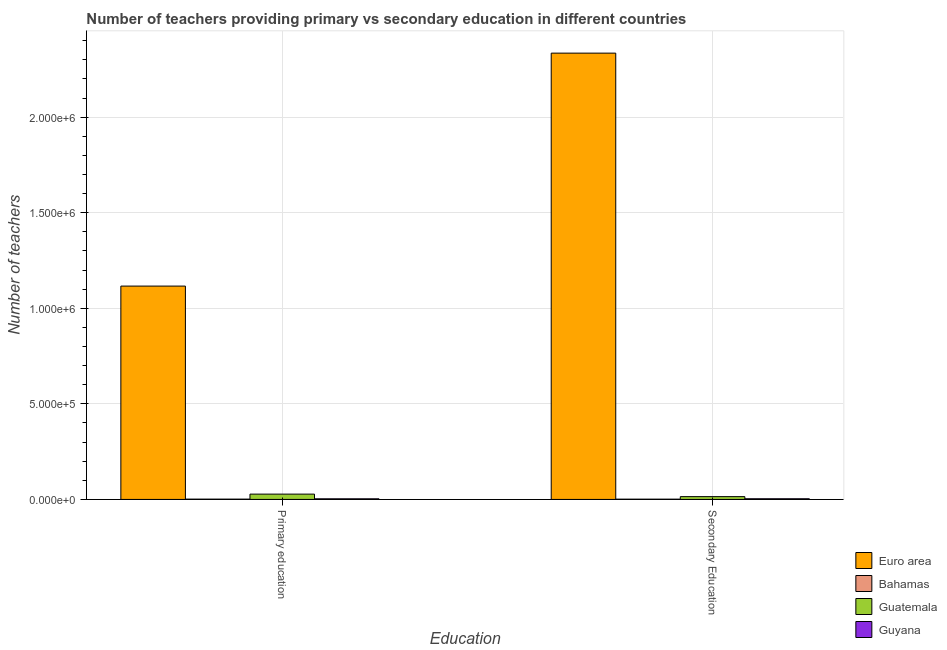How many different coloured bars are there?
Give a very brief answer. 4. How many bars are there on the 1st tick from the left?
Your response must be concise. 4. How many bars are there on the 1st tick from the right?
Offer a terse response. 4. What is the label of the 1st group of bars from the left?
Offer a very short reply. Primary education. What is the number of primary teachers in Guyana?
Provide a succinct answer. 3284. Across all countries, what is the maximum number of secondary teachers?
Ensure brevity in your answer.  2.34e+06. Across all countries, what is the minimum number of primary teachers?
Your response must be concise. 1561. In which country was the number of primary teachers minimum?
Make the answer very short. Bahamas. What is the total number of secondary teachers in the graph?
Provide a succinct answer. 2.35e+06. What is the difference between the number of secondary teachers in Euro area and that in Guyana?
Offer a very short reply. 2.33e+06. What is the difference between the number of primary teachers in Guyana and the number of secondary teachers in Euro area?
Make the answer very short. -2.33e+06. What is the average number of secondary teachers per country?
Provide a short and direct response. 5.89e+05. What is the difference between the number of secondary teachers and number of primary teachers in Euro area?
Provide a short and direct response. 1.22e+06. In how many countries, is the number of primary teachers greater than 1600000 ?
Give a very brief answer. 0. What is the ratio of the number of primary teachers in Guatemala to that in Bahamas?
Your answer should be very brief. 17.81. Is the number of secondary teachers in Guyana less than that in Bahamas?
Keep it short and to the point. No. What does the 4th bar from the left in Secondary Education represents?
Your answer should be very brief. Guyana. What does the 2nd bar from the right in Primary education represents?
Offer a very short reply. Guatemala. Are all the bars in the graph horizontal?
Provide a succinct answer. No. How many countries are there in the graph?
Your response must be concise. 4. What is the difference between two consecutive major ticks on the Y-axis?
Your answer should be compact. 5.00e+05. Does the graph contain grids?
Provide a short and direct response. Yes. What is the title of the graph?
Your answer should be compact. Number of teachers providing primary vs secondary education in different countries. What is the label or title of the X-axis?
Offer a terse response. Education. What is the label or title of the Y-axis?
Provide a succinct answer. Number of teachers. What is the Number of teachers of Euro area in Primary education?
Provide a succinct answer. 1.12e+06. What is the Number of teachers in Bahamas in Primary education?
Make the answer very short. 1561. What is the Number of teachers in Guatemala in Primary education?
Keep it short and to the point. 2.78e+04. What is the Number of teachers in Guyana in Primary education?
Make the answer very short. 3284. What is the Number of teachers of Euro area in Secondary Education?
Offer a very short reply. 2.34e+06. What is the Number of teachers in Bahamas in Secondary Education?
Keep it short and to the point. 1344. What is the Number of teachers of Guatemala in Secondary Education?
Your response must be concise. 1.46e+04. What is the Number of teachers in Guyana in Secondary Education?
Give a very brief answer. 3506. Across all Education, what is the maximum Number of teachers in Euro area?
Offer a very short reply. 2.34e+06. Across all Education, what is the maximum Number of teachers of Bahamas?
Your answer should be compact. 1561. Across all Education, what is the maximum Number of teachers of Guatemala?
Your response must be concise. 2.78e+04. Across all Education, what is the maximum Number of teachers of Guyana?
Your response must be concise. 3506. Across all Education, what is the minimum Number of teachers of Euro area?
Make the answer very short. 1.12e+06. Across all Education, what is the minimum Number of teachers of Bahamas?
Keep it short and to the point. 1344. Across all Education, what is the minimum Number of teachers in Guatemala?
Your response must be concise. 1.46e+04. Across all Education, what is the minimum Number of teachers of Guyana?
Provide a short and direct response. 3284. What is the total Number of teachers of Euro area in the graph?
Ensure brevity in your answer.  3.45e+06. What is the total Number of teachers in Bahamas in the graph?
Your answer should be compact. 2905. What is the total Number of teachers in Guatemala in the graph?
Keep it short and to the point. 4.24e+04. What is the total Number of teachers of Guyana in the graph?
Your answer should be very brief. 6790. What is the difference between the Number of teachers in Euro area in Primary education and that in Secondary Education?
Offer a terse response. -1.22e+06. What is the difference between the Number of teachers in Bahamas in Primary education and that in Secondary Education?
Make the answer very short. 217. What is the difference between the Number of teachers of Guatemala in Primary education and that in Secondary Education?
Provide a succinct answer. 1.32e+04. What is the difference between the Number of teachers of Guyana in Primary education and that in Secondary Education?
Keep it short and to the point. -222. What is the difference between the Number of teachers of Euro area in Primary education and the Number of teachers of Bahamas in Secondary Education?
Offer a very short reply. 1.11e+06. What is the difference between the Number of teachers in Euro area in Primary education and the Number of teachers in Guatemala in Secondary Education?
Make the answer very short. 1.10e+06. What is the difference between the Number of teachers of Euro area in Primary education and the Number of teachers of Guyana in Secondary Education?
Give a very brief answer. 1.11e+06. What is the difference between the Number of teachers in Bahamas in Primary education and the Number of teachers in Guatemala in Secondary Education?
Offer a terse response. -1.31e+04. What is the difference between the Number of teachers of Bahamas in Primary education and the Number of teachers of Guyana in Secondary Education?
Your answer should be very brief. -1945. What is the difference between the Number of teachers of Guatemala in Primary education and the Number of teachers of Guyana in Secondary Education?
Give a very brief answer. 2.43e+04. What is the average Number of teachers of Euro area per Education?
Make the answer very short. 1.73e+06. What is the average Number of teachers in Bahamas per Education?
Your answer should be compact. 1452.5. What is the average Number of teachers in Guatemala per Education?
Your answer should be very brief. 2.12e+04. What is the average Number of teachers in Guyana per Education?
Give a very brief answer. 3395. What is the difference between the Number of teachers in Euro area and Number of teachers in Bahamas in Primary education?
Give a very brief answer. 1.11e+06. What is the difference between the Number of teachers in Euro area and Number of teachers in Guatemala in Primary education?
Provide a short and direct response. 1.09e+06. What is the difference between the Number of teachers of Euro area and Number of teachers of Guyana in Primary education?
Provide a short and direct response. 1.11e+06. What is the difference between the Number of teachers in Bahamas and Number of teachers in Guatemala in Primary education?
Give a very brief answer. -2.62e+04. What is the difference between the Number of teachers of Bahamas and Number of teachers of Guyana in Primary education?
Offer a terse response. -1723. What is the difference between the Number of teachers in Guatemala and Number of teachers in Guyana in Primary education?
Offer a very short reply. 2.45e+04. What is the difference between the Number of teachers of Euro area and Number of teachers of Bahamas in Secondary Education?
Provide a short and direct response. 2.33e+06. What is the difference between the Number of teachers in Euro area and Number of teachers in Guatemala in Secondary Education?
Ensure brevity in your answer.  2.32e+06. What is the difference between the Number of teachers in Euro area and Number of teachers in Guyana in Secondary Education?
Offer a very short reply. 2.33e+06. What is the difference between the Number of teachers of Bahamas and Number of teachers of Guatemala in Secondary Education?
Your answer should be very brief. -1.33e+04. What is the difference between the Number of teachers in Bahamas and Number of teachers in Guyana in Secondary Education?
Give a very brief answer. -2162. What is the difference between the Number of teachers of Guatemala and Number of teachers of Guyana in Secondary Education?
Your answer should be compact. 1.11e+04. What is the ratio of the Number of teachers of Euro area in Primary education to that in Secondary Education?
Give a very brief answer. 0.48. What is the ratio of the Number of teachers in Bahamas in Primary education to that in Secondary Education?
Your answer should be compact. 1.16. What is the ratio of the Number of teachers of Guatemala in Primary education to that in Secondary Education?
Your response must be concise. 1.9. What is the ratio of the Number of teachers in Guyana in Primary education to that in Secondary Education?
Provide a succinct answer. 0.94. What is the difference between the highest and the second highest Number of teachers in Euro area?
Offer a terse response. 1.22e+06. What is the difference between the highest and the second highest Number of teachers of Bahamas?
Make the answer very short. 217. What is the difference between the highest and the second highest Number of teachers of Guatemala?
Your response must be concise. 1.32e+04. What is the difference between the highest and the second highest Number of teachers in Guyana?
Ensure brevity in your answer.  222. What is the difference between the highest and the lowest Number of teachers in Euro area?
Provide a succinct answer. 1.22e+06. What is the difference between the highest and the lowest Number of teachers in Bahamas?
Keep it short and to the point. 217. What is the difference between the highest and the lowest Number of teachers in Guatemala?
Offer a terse response. 1.32e+04. What is the difference between the highest and the lowest Number of teachers of Guyana?
Ensure brevity in your answer.  222. 